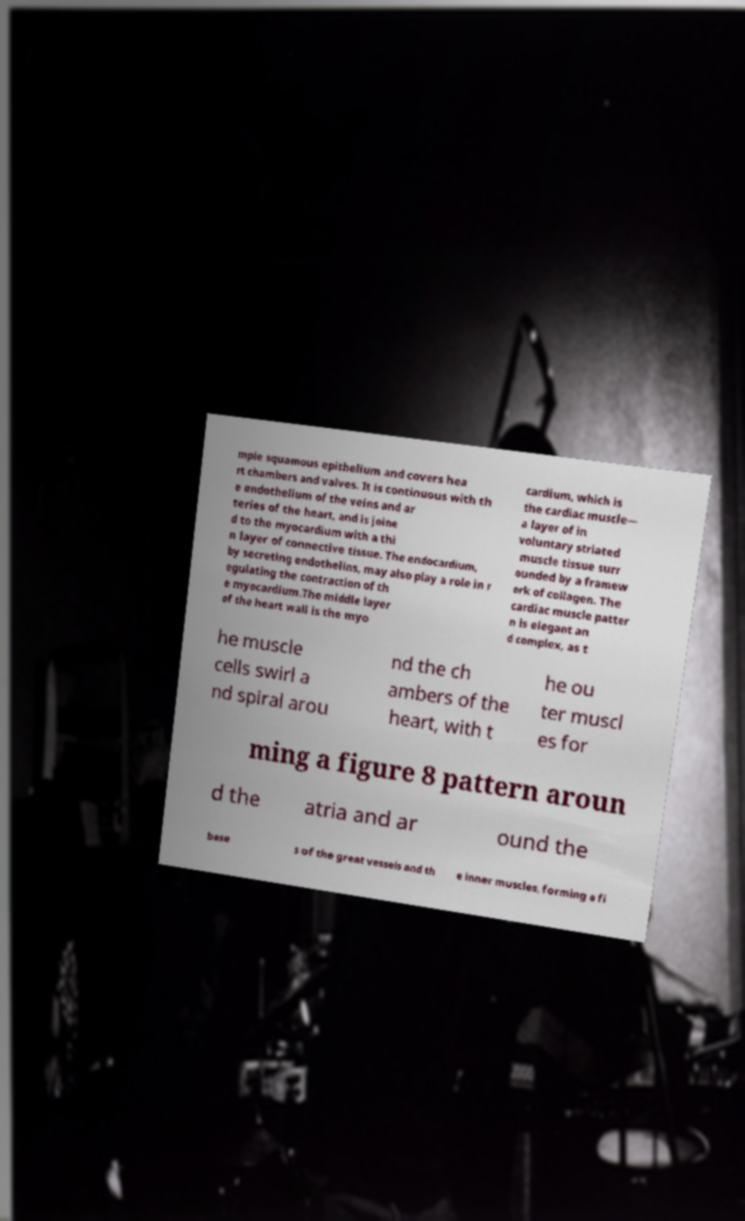For documentation purposes, I need the text within this image transcribed. Could you provide that? mple squamous epithelium and covers hea rt chambers and valves. It is continuous with th e endothelium of the veins and ar teries of the heart, and is joine d to the myocardium with a thi n layer of connective tissue. The endocardium, by secreting endothelins, may also play a role in r egulating the contraction of th e myocardium.The middle layer of the heart wall is the myo cardium, which is the cardiac muscle— a layer of in voluntary striated muscle tissue surr ounded by a framew ork of collagen. The cardiac muscle patter n is elegant an d complex, as t he muscle cells swirl a nd spiral arou nd the ch ambers of the heart, with t he ou ter muscl es for ming a figure 8 pattern aroun d the atria and ar ound the base s of the great vessels and th e inner muscles, forming a fi 